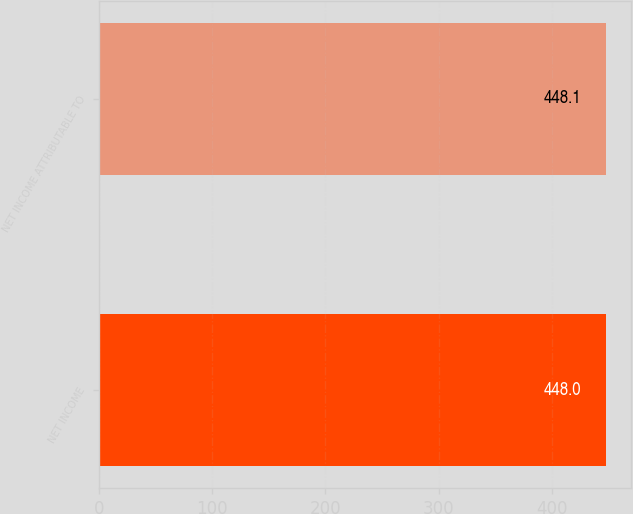Convert chart. <chart><loc_0><loc_0><loc_500><loc_500><bar_chart><fcel>NET INCOME<fcel>NET INCOME ATTRIBUTABLE TO<nl><fcel>448<fcel>448.1<nl></chart> 